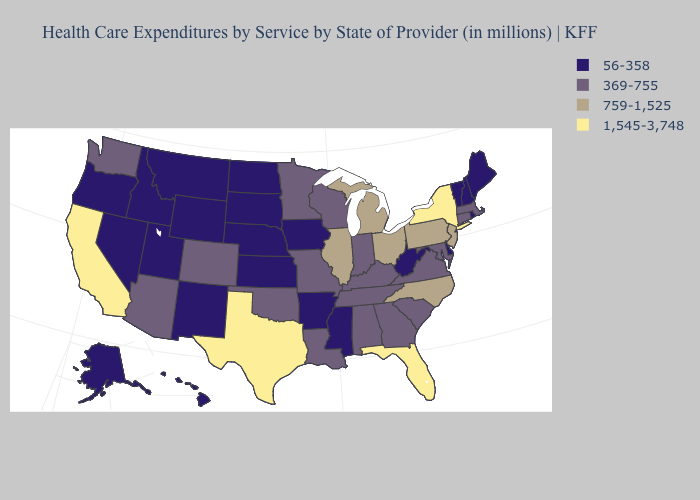Name the states that have a value in the range 369-755?
Give a very brief answer. Alabama, Arizona, Colorado, Connecticut, Georgia, Indiana, Kentucky, Louisiana, Maryland, Massachusetts, Minnesota, Missouri, Oklahoma, South Carolina, Tennessee, Virginia, Washington, Wisconsin. Does Florida have the highest value in the USA?
Give a very brief answer. Yes. What is the value of Illinois?
Give a very brief answer. 759-1,525. Does Oregon have the lowest value in the West?
Be succinct. Yes. What is the value of Alaska?
Answer briefly. 56-358. Does Arkansas have the highest value in the USA?
Give a very brief answer. No. What is the lowest value in states that border Montana?
Write a very short answer. 56-358. Which states have the highest value in the USA?
Be succinct. California, Florida, New York, Texas. Does the map have missing data?
Concise answer only. No. What is the value of New York?
Short answer required. 1,545-3,748. What is the lowest value in the West?
Write a very short answer. 56-358. How many symbols are there in the legend?
Answer briefly. 4. Does Ohio have a lower value than Delaware?
Be succinct. No. 